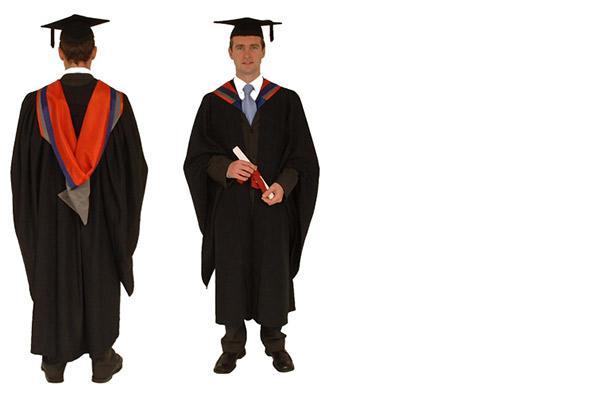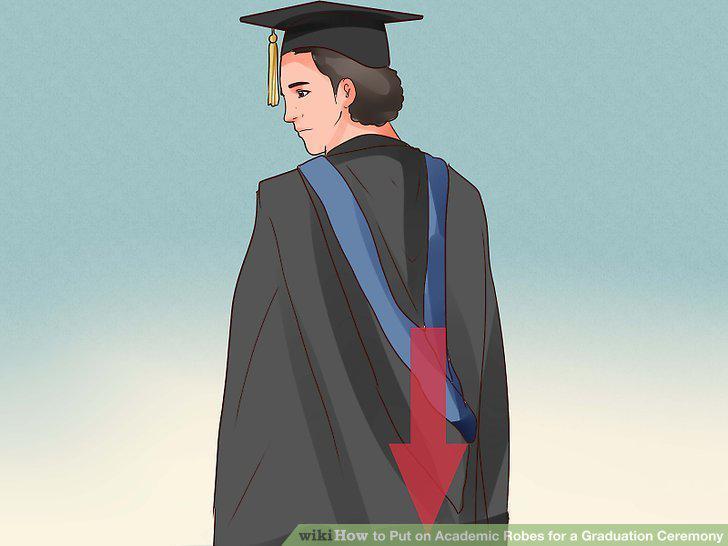The first image is the image on the left, the second image is the image on the right. Analyze the images presented: Is the assertion "An image shows male modeling back and front views of graduation garb." valid? Answer yes or no. Yes. The first image is the image on the left, the second image is the image on the right. Considering the images on both sides, is "there is exactly one person in the image on the left" valid? Answer yes or no. No. 